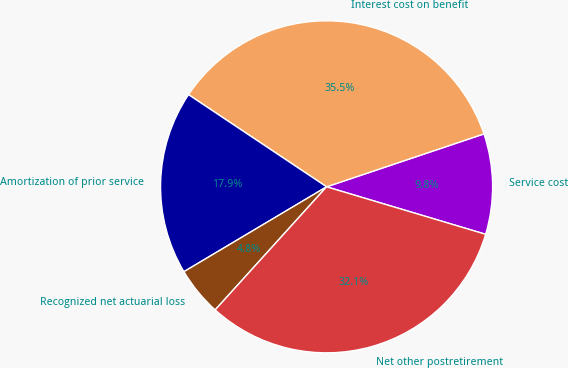Convert chart to OTSL. <chart><loc_0><loc_0><loc_500><loc_500><pie_chart><fcel>Service cost<fcel>Interest cost on benefit<fcel>Amortization of prior service<fcel>Recognized net actuarial loss<fcel>Net other postretirement<nl><fcel>9.78%<fcel>35.47%<fcel>17.91%<fcel>4.75%<fcel>32.09%<nl></chart> 